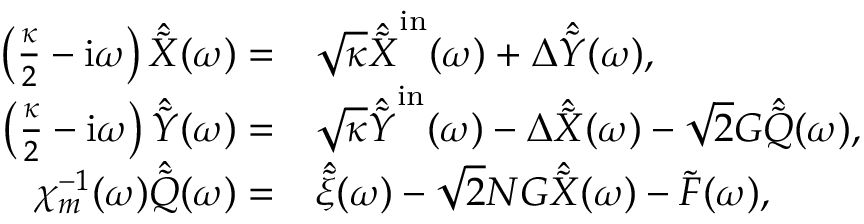Convert formula to latex. <formula><loc_0><loc_0><loc_500><loc_500>\begin{array} { r l } { \left ( \frac { \kappa } { 2 } - i \omega \right ) \hat { \tilde { X } } ( \omega ) = } & \sqrt { \kappa } \hat { \tilde { X } } ^ { i n } ( \omega ) + \Delta \hat { \tilde { Y } } ( \omega ) , } \\ { \left ( \frac { \kappa } { 2 } - i \omega \right ) \hat { \tilde { Y } } ( \omega ) = } & \sqrt { \kappa } \hat { \tilde { Y } } ^ { i n } ( \omega ) - \Delta \hat { \tilde { X } } ( \omega ) - \sqrt { 2 } G \hat { \tilde { Q } } ( \omega ) , } \\ { \chi _ { m } ^ { - 1 } ( \omega ) \hat { \tilde { Q } } ( \omega ) = } & \hat { \tilde { \xi } } ( \omega ) - \sqrt { 2 } N G \hat { \tilde { X } } ( \omega ) - \tilde { F } ( \omega ) , } \end{array}</formula> 